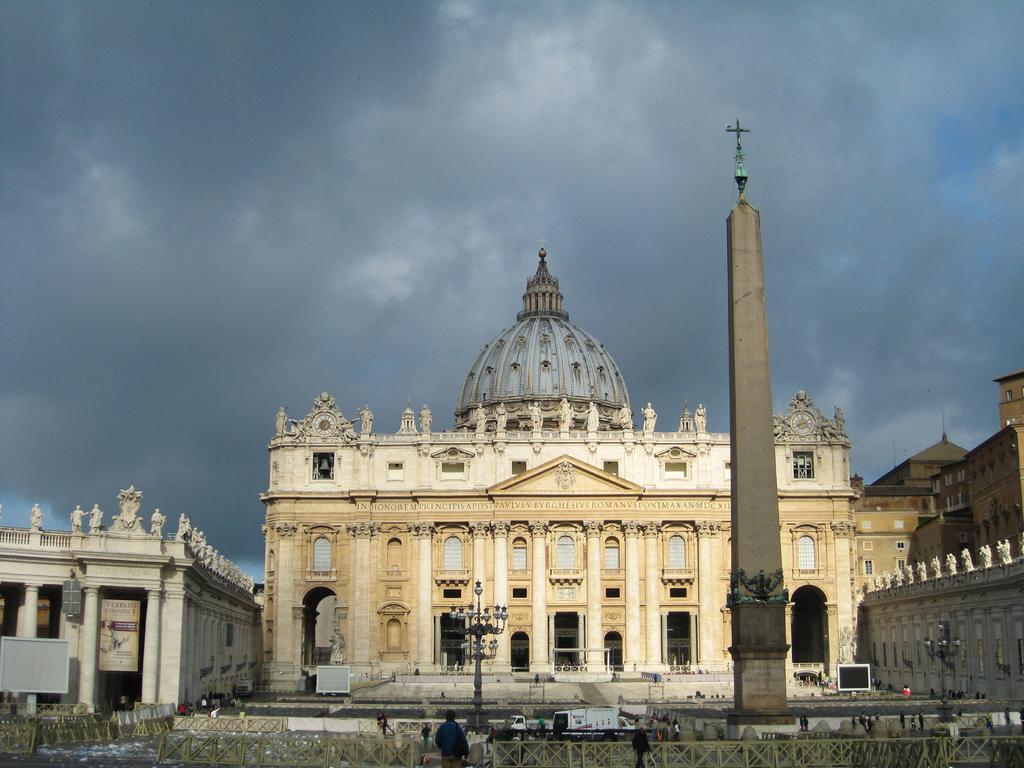Please provide a concise description of this image. In this image we can see few buildings. There is a cloudy sky in the image. There are few people in the image. There are few lamps and a tomb in the image. 